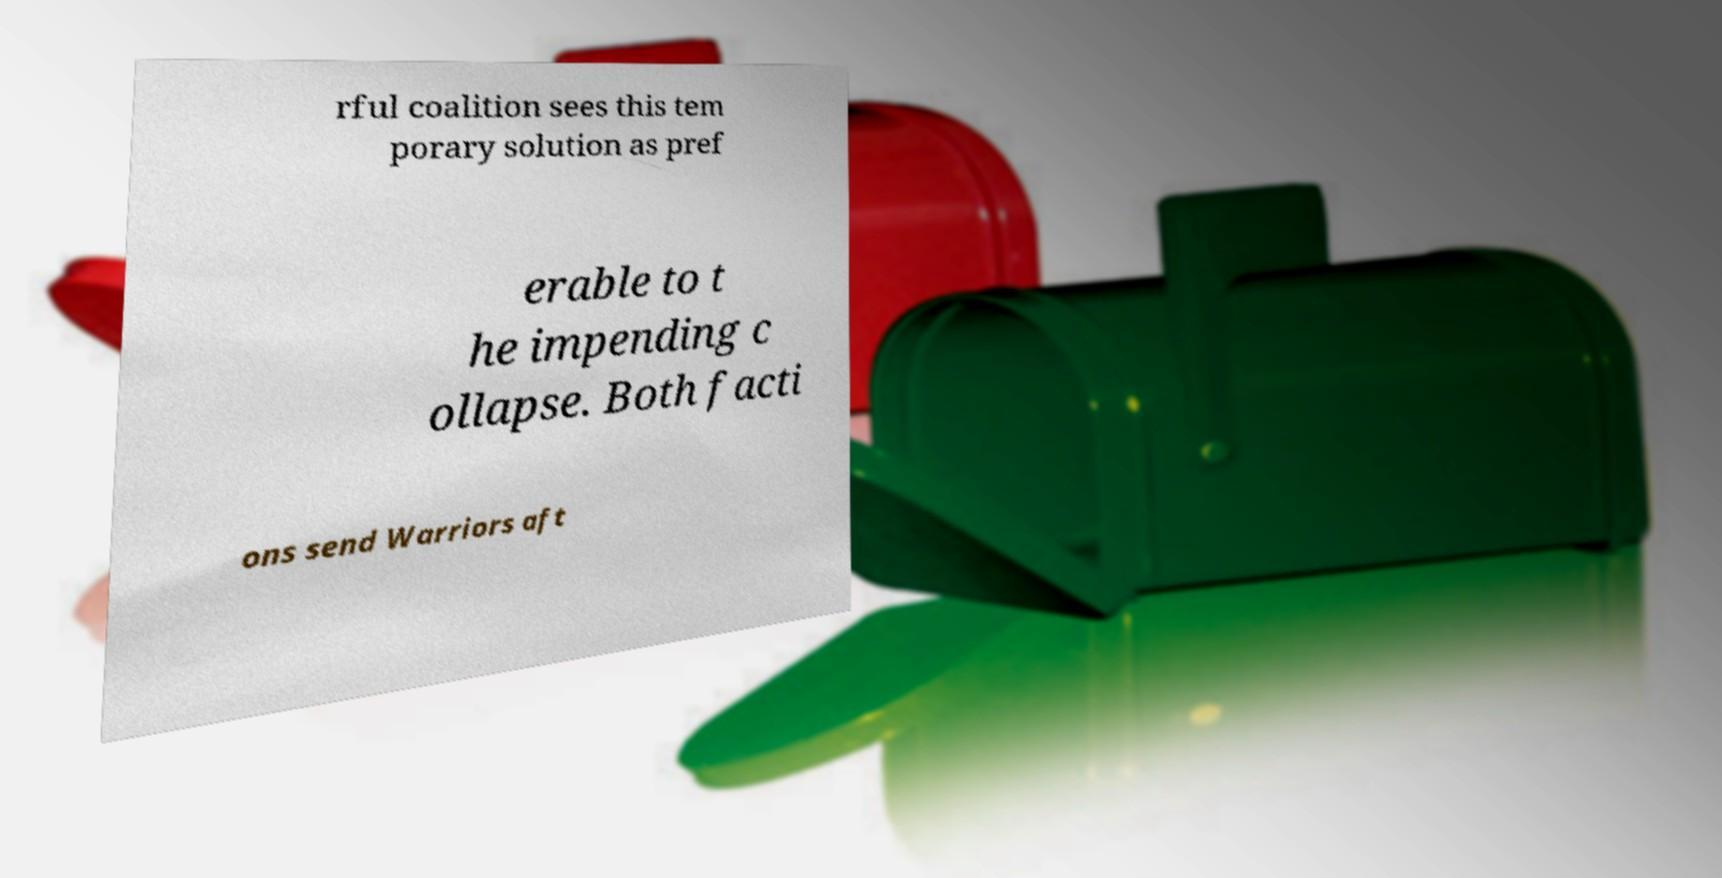Could you extract and type out the text from this image? rful coalition sees this tem porary solution as pref erable to t he impending c ollapse. Both facti ons send Warriors aft 